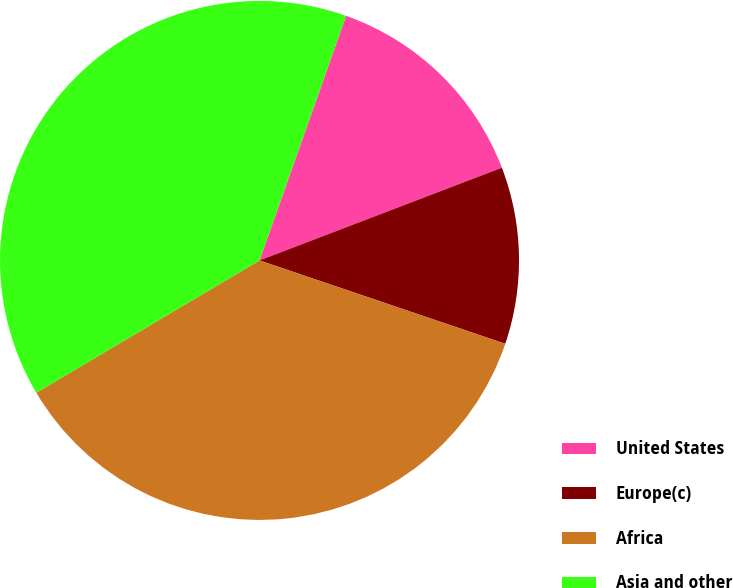<chart> <loc_0><loc_0><loc_500><loc_500><pie_chart><fcel>United States<fcel>Europe(c)<fcel>Africa<fcel>Asia and other<nl><fcel>13.77%<fcel>11.02%<fcel>36.28%<fcel>38.93%<nl></chart> 